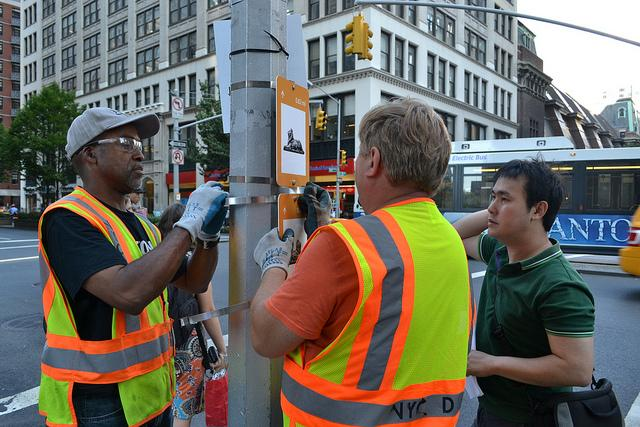What are the signs for? Please explain your reasoning. missing dogs. There are dogs on the signs. 